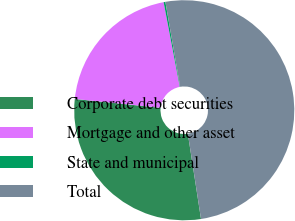Convert chart to OTSL. <chart><loc_0><loc_0><loc_500><loc_500><pie_chart><fcel>Corporate debt securities<fcel>Mortgage and other asset<fcel>State and municipal<fcel>Total<nl><fcel>29.07%<fcel>20.36%<fcel>0.26%<fcel>50.3%<nl></chart> 